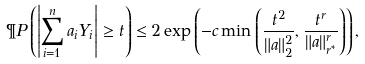Convert formula to latex. <formula><loc_0><loc_0><loc_500><loc_500>\P P \left ( \left | \sum _ { i = 1 } ^ { n } a _ { i } Y _ { i } \right | \geq t \right ) \leq 2 \exp \left ( - c \min \left ( \frac { t ^ { 2 } } { \| a \| _ { 2 } ^ { 2 } } , \frac { t ^ { r } } { \| a \| _ { r ^ { \ast } } ^ { r } } \right ) \right ) ,</formula> 